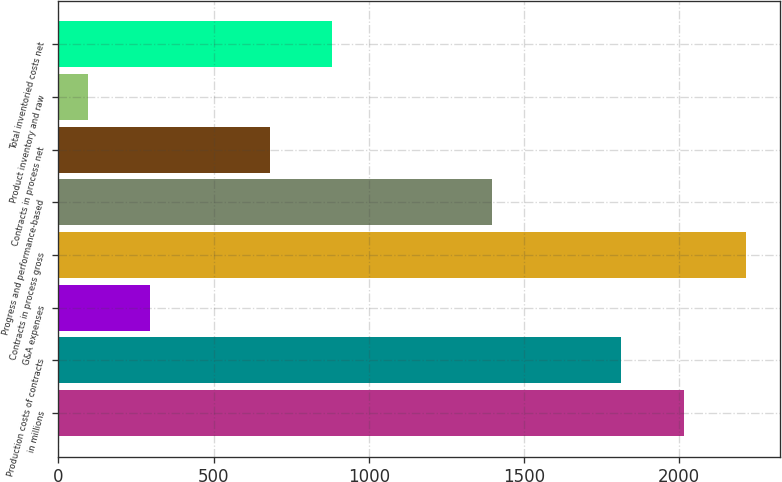Convert chart to OTSL. <chart><loc_0><loc_0><loc_500><loc_500><bar_chart><fcel>in millions<fcel>Production costs of contracts<fcel>G&A expenses<fcel>Contracts in process gross<fcel>Progress and performance-based<fcel>Contracts in process net<fcel>Product inventory and raw<fcel>Total inventoried costs net<nl><fcel>2017<fcel>1813<fcel>295.2<fcel>2215.2<fcel>1396<fcel>683<fcel>97<fcel>881.2<nl></chart> 